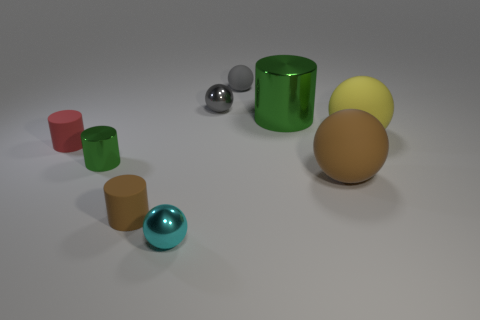What textures can be observed on the various objects in the image? The objects in the image display a range of textures. The larger cylinders and spheres have a smooth and shiny appearance indicative of a reflective material, possibly metal or polished plastic. In contrast, the surface on which the objects rest appears matte and slightly textured, possibly a flooring with a fine, non-reflective finish. 